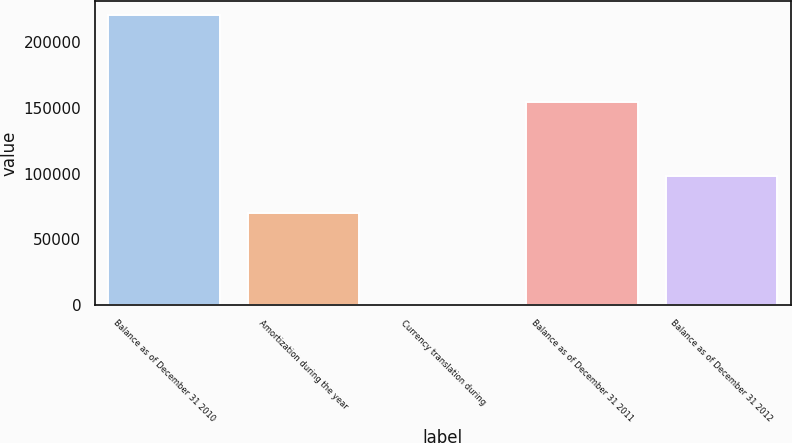<chart> <loc_0><loc_0><loc_500><loc_500><bar_chart><fcel>Balance as of December 31 2010<fcel>Amortization during the year<fcel>Currency translation during<fcel>Balance as of December 31 2011<fcel>Balance as of December 31 2012<nl><fcel>220237<fcel>70364<fcel>386<fcel>154668<fcel>98296<nl></chart> 